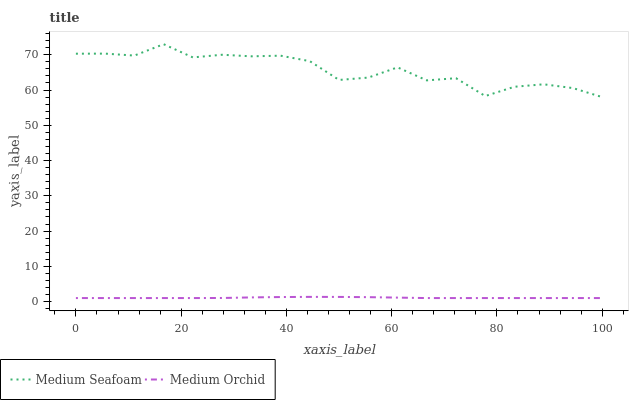Does Medium Orchid have the minimum area under the curve?
Answer yes or no. Yes. Does Medium Seafoam have the maximum area under the curve?
Answer yes or no. Yes. Does Medium Seafoam have the minimum area under the curve?
Answer yes or no. No. Is Medium Orchid the smoothest?
Answer yes or no. Yes. Is Medium Seafoam the roughest?
Answer yes or no. Yes. Is Medium Seafoam the smoothest?
Answer yes or no. No. Does Medium Seafoam have the lowest value?
Answer yes or no. No. Does Medium Seafoam have the highest value?
Answer yes or no. Yes. Is Medium Orchid less than Medium Seafoam?
Answer yes or no. Yes. Is Medium Seafoam greater than Medium Orchid?
Answer yes or no. Yes. Does Medium Orchid intersect Medium Seafoam?
Answer yes or no. No. 